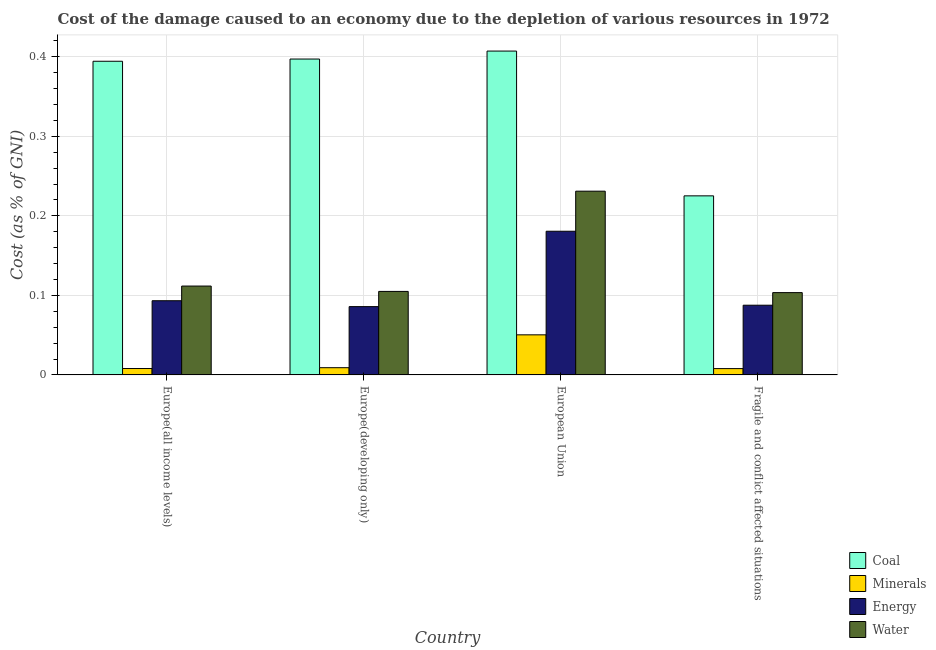How many different coloured bars are there?
Keep it short and to the point. 4. Are the number of bars on each tick of the X-axis equal?
Offer a very short reply. Yes. What is the label of the 3rd group of bars from the left?
Your response must be concise. European Union. In how many cases, is the number of bars for a given country not equal to the number of legend labels?
Give a very brief answer. 0. What is the cost of damage due to depletion of coal in Europe(all income levels)?
Keep it short and to the point. 0.39. Across all countries, what is the maximum cost of damage due to depletion of minerals?
Your answer should be compact. 0.05. Across all countries, what is the minimum cost of damage due to depletion of water?
Offer a very short reply. 0.1. In which country was the cost of damage due to depletion of water minimum?
Ensure brevity in your answer.  Fragile and conflict affected situations. What is the total cost of damage due to depletion of water in the graph?
Your answer should be compact. 0.55. What is the difference between the cost of damage due to depletion of energy in Europe(all income levels) and that in Europe(developing only)?
Provide a succinct answer. 0.01. What is the difference between the cost of damage due to depletion of energy in Europe(all income levels) and the cost of damage due to depletion of coal in Europe(developing only)?
Offer a very short reply. -0.3. What is the average cost of damage due to depletion of water per country?
Keep it short and to the point. 0.14. What is the difference between the cost of damage due to depletion of coal and cost of damage due to depletion of water in Europe(developing only)?
Provide a succinct answer. 0.29. What is the ratio of the cost of damage due to depletion of energy in Europe(all income levels) to that in Fragile and conflict affected situations?
Offer a very short reply. 1.06. Is the cost of damage due to depletion of water in European Union less than that in Fragile and conflict affected situations?
Your response must be concise. No. Is the difference between the cost of damage due to depletion of energy in European Union and Fragile and conflict affected situations greater than the difference between the cost of damage due to depletion of coal in European Union and Fragile and conflict affected situations?
Offer a very short reply. No. What is the difference between the highest and the second highest cost of damage due to depletion of energy?
Provide a short and direct response. 0.09. What is the difference between the highest and the lowest cost of damage due to depletion of energy?
Your answer should be compact. 0.09. In how many countries, is the cost of damage due to depletion of water greater than the average cost of damage due to depletion of water taken over all countries?
Ensure brevity in your answer.  1. Is it the case that in every country, the sum of the cost of damage due to depletion of water and cost of damage due to depletion of energy is greater than the sum of cost of damage due to depletion of coal and cost of damage due to depletion of minerals?
Offer a terse response. No. What does the 2nd bar from the left in Europe(developing only) represents?
Provide a short and direct response. Minerals. What does the 4th bar from the right in Europe(developing only) represents?
Provide a succinct answer. Coal. Is it the case that in every country, the sum of the cost of damage due to depletion of coal and cost of damage due to depletion of minerals is greater than the cost of damage due to depletion of energy?
Your answer should be compact. Yes. Are all the bars in the graph horizontal?
Provide a short and direct response. No. How many countries are there in the graph?
Offer a terse response. 4. What is the difference between two consecutive major ticks on the Y-axis?
Provide a succinct answer. 0.1. Are the values on the major ticks of Y-axis written in scientific E-notation?
Provide a succinct answer. No. Does the graph contain any zero values?
Make the answer very short. No. Does the graph contain grids?
Your response must be concise. Yes. Where does the legend appear in the graph?
Offer a terse response. Bottom right. How many legend labels are there?
Provide a succinct answer. 4. How are the legend labels stacked?
Give a very brief answer. Vertical. What is the title of the graph?
Give a very brief answer. Cost of the damage caused to an economy due to the depletion of various resources in 1972 . What is the label or title of the Y-axis?
Ensure brevity in your answer.  Cost (as % of GNI). What is the Cost (as % of GNI) of Coal in Europe(all income levels)?
Make the answer very short. 0.39. What is the Cost (as % of GNI) of Minerals in Europe(all income levels)?
Provide a succinct answer. 0.01. What is the Cost (as % of GNI) in Energy in Europe(all income levels)?
Your response must be concise. 0.09. What is the Cost (as % of GNI) of Water in Europe(all income levels)?
Your answer should be compact. 0.11. What is the Cost (as % of GNI) in Coal in Europe(developing only)?
Make the answer very short. 0.4. What is the Cost (as % of GNI) of Minerals in Europe(developing only)?
Your answer should be compact. 0.01. What is the Cost (as % of GNI) in Energy in Europe(developing only)?
Your answer should be very brief. 0.09. What is the Cost (as % of GNI) of Water in Europe(developing only)?
Your answer should be compact. 0.1. What is the Cost (as % of GNI) of Coal in European Union?
Offer a very short reply. 0.41. What is the Cost (as % of GNI) in Minerals in European Union?
Keep it short and to the point. 0.05. What is the Cost (as % of GNI) of Energy in European Union?
Offer a terse response. 0.18. What is the Cost (as % of GNI) in Water in European Union?
Your answer should be very brief. 0.23. What is the Cost (as % of GNI) in Coal in Fragile and conflict affected situations?
Make the answer very short. 0.23. What is the Cost (as % of GNI) in Minerals in Fragile and conflict affected situations?
Provide a short and direct response. 0.01. What is the Cost (as % of GNI) of Energy in Fragile and conflict affected situations?
Provide a succinct answer. 0.09. What is the Cost (as % of GNI) of Water in Fragile and conflict affected situations?
Offer a very short reply. 0.1. Across all countries, what is the maximum Cost (as % of GNI) of Coal?
Give a very brief answer. 0.41. Across all countries, what is the maximum Cost (as % of GNI) of Minerals?
Offer a terse response. 0.05. Across all countries, what is the maximum Cost (as % of GNI) in Energy?
Your answer should be compact. 0.18. Across all countries, what is the maximum Cost (as % of GNI) of Water?
Your answer should be compact. 0.23. Across all countries, what is the minimum Cost (as % of GNI) in Coal?
Your response must be concise. 0.23. Across all countries, what is the minimum Cost (as % of GNI) in Minerals?
Provide a succinct answer. 0.01. Across all countries, what is the minimum Cost (as % of GNI) in Energy?
Ensure brevity in your answer.  0.09. Across all countries, what is the minimum Cost (as % of GNI) in Water?
Your response must be concise. 0.1. What is the total Cost (as % of GNI) in Coal in the graph?
Make the answer very short. 1.42. What is the total Cost (as % of GNI) of Minerals in the graph?
Offer a terse response. 0.08. What is the total Cost (as % of GNI) of Energy in the graph?
Make the answer very short. 0.45. What is the total Cost (as % of GNI) in Water in the graph?
Keep it short and to the point. 0.55. What is the difference between the Cost (as % of GNI) of Coal in Europe(all income levels) and that in Europe(developing only)?
Your response must be concise. -0. What is the difference between the Cost (as % of GNI) in Minerals in Europe(all income levels) and that in Europe(developing only)?
Offer a very short reply. -0. What is the difference between the Cost (as % of GNI) in Energy in Europe(all income levels) and that in Europe(developing only)?
Provide a short and direct response. 0.01. What is the difference between the Cost (as % of GNI) in Water in Europe(all income levels) and that in Europe(developing only)?
Ensure brevity in your answer.  0.01. What is the difference between the Cost (as % of GNI) of Coal in Europe(all income levels) and that in European Union?
Provide a short and direct response. -0.01. What is the difference between the Cost (as % of GNI) in Minerals in Europe(all income levels) and that in European Union?
Provide a succinct answer. -0.04. What is the difference between the Cost (as % of GNI) in Energy in Europe(all income levels) and that in European Union?
Provide a short and direct response. -0.09. What is the difference between the Cost (as % of GNI) of Water in Europe(all income levels) and that in European Union?
Offer a terse response. -0.12. What is the difference between the Cost (as % of GNI) of Coal in Europe(all income levels) and that in Fragile and conflict affected situations?
Your answer should be compact. 0.17. What is the difference between the Cost (as % of GNI) in Energy in Europe(all income levels) and that in Fragile and conflict affected situations?
Your answer should be very brief. 0.01. What is the difference between the Cost (as % of GNI) of Water in Europe(all income levels) and that in Fragile and conflict affected situations?
Your answer should be compact. 0.01. What is the difference between the Cost (as % of GNI) of Coal in Europe(developing only) and that in European Union?
Offer a very short reply. -0.01. What is the difference between the Cost (as % of GNI) of Minerals in Europe(developing only) and that in European Union?
Your answer should be very brief. -0.04. What is the difference between the Cost (as % of GNI) of Energy in Europe(developing only) and that in European Union?
Provide a short and direct response. -0.09. What is the difference between the Cost (as % of GNI) of Water in Europe(developing only) and that in European Union?
Ensure brevity in your answer.  -0.13. What is the difference between the Cost (as % of GNI) in Coal in Europe(developing only) and that in Fragile and conflict affected situations?
Keep it short and to the point. 0.17. What is the difference between the Cost (as % of GNI) of Minerals in Europe(developing only) and that in Fragile and conflict affected situations?
Provide a succinct answer. 0. What is the difference between the Cost (as % of GNI) of Energy in Europe(developing only) and that in Fragile and conflict affected situations?
Keep it short and to the point. -0. What is the difference between the Cost (as % of GNI) in Water in Europe(developing only) and that in Fragile and conflict affected situations?
Offer a terse response. 0. What is the difference between the Cost (as % of GNI) in Coal in European Union and that in Fragile and conflict affected situations?
Offer a very short reply. 0.18. What is the difference between the Cost (as % of GNI) in Minerals in European Union and that in Fragile and conflict affected situations?
Your answer should be compact. 0.04. What is the difference between the Cost (as % of GNI) in Energy in European Union and that in Fragile and conflict affected situations?
Ensure brevity in your answer.  0.09. What is the difference between the Cost (as % of GNI) of Water in European Union and that in Fragile and conflict affected situations?
Offer a terse response. 0.13. What is the difference between the Cost (as % of GNI) in Coal in Europe(all income levels) and the Cost (as % of GNI) in Minerals in Europe(developing only)?
Keep it short and to the point. 0.39. What is the difference between the Cost (as % of GNI) of Coal in Europe(all income levels) and the Cost (as % of GNI) of Energy in Europe(developing only)?
Keep it short and to the point. 0.31. What is the difference between the Cost (as % of GNI) of Coal in Europe(all income levels) and the Cost (as % of GNI) of Water in Europe(developing only)?
Give a very brief answer. 0.29. What is the difference between the Cost (as % of GNI) in Minerals in Europe(all income levels) and the Cost (as % of GNI) in Energy in Europe(developing only)?
Provide a succinct answer. -0.08. What is the difference between the Cost (as % of GNI) in Minerals in Europe(all income levels) and the Cost (as % of GNI) in Water in Europe(developing only)?
Keep it short and to the point. -0.1. What is the difference between the Cost (as % of GNI) in Energy in Europe(all income levels) and the Cost (as % of GNI) in Water in Europe(developing only)?
Offer a very short reply. -0.01. What is the difference between the Cost (as % of GNI) of Coal in Europe(all income levels) and the Cost (as % of GNI) of Minerals in European Union?
Your response must be concise. 0.34. What is the difference between the Cost (as % of GNI) of Coal in Europe(all income levels) and the Cost (as % of GNI) of Energy in European Union?
Ensure brevity in your answer.  0.21. What is the difference between the Cost (as % of GNI) in Coal in Europe(all income levels) and the Cost (as % of GNI) in Water in European Union?
Make the answer very short. 0.16. What is the difference between the Cost (as % of GNI) of Minerals in Europe(all income levels) and the Cost (as % of GNI) of Energy in European Union?
Your answer should be compact. -0.17. What is the difference between the Cost (as % of GNI) of Minerals in Europe(all income levels) and the Cost (as % of GNI) of Water in European Union?
Offer a very short reply. -0.22. What is the difference between the Cost (as % of GNI) of Energy in Europe(all income levels) and the Cost (as % of GNI) of Water in European Union?
Your response must be concise. -0.14. What is the difference between the Cost (as % of GNI) of Coal in Europe(all income levels) and the Cost (as % of GNI) of Minerals in Fragile and conflict affected situations?
Provide a succinct answer. 0.39. What is the difference between the Cost (as % of GNI) in Coal in Europe(all income levels) and the Cost (as % of GNI) in Energy in Fragile and conflict affected situations?
Your answer should be very brief. 0.31. What is the difference between the Cost (as % of GNI) in Coal in Europe(all income levels) and the Cost (as % of GNI) in Water in Fragile and conflict affected situations?
Offer a very short reply. 0.29. What is the difference between the Cost (as % of GNI) in Minerals in Europe(all income levels) and the Cost (as % of GNI) in Energy in Fragile and conflict affected situations?
Your response must be concise. -0.08. What is the difference between the Cost (as % of GNI) in Minerals in Europe(all income levels) and the Cost (as % of GNI) in Water in Fragile and conflict affected situations?
Your answer should be compact. -0.1. What is the difference between the Cost (as % of GNI) in Energy in Europe(all income levels) and the Cost (as % of GNI) in Water in Fragile and conflict affected situations?
Offer a terse response. -0.01. What is the difference between the Cost (as % of GNI) in Coal in Europe(developing only) and the Cost (as % of GNI) in Minerals in European Union?
Your answer should be compact. 0.35. What is the difference between the Cost (as % of GNI) of Coal in Europe(developing only) and the Cost (as % of GNI) of Energy in European Union?
Your answer should be compact. 0.22. What is the difference between the Cost (as % of GNI) of Coal in Europe(developing only) and the Cost (as % of GNI) of Water in European Union?
Offer a very short reply. 0.17. What is the difference between the Cost (as % of GNI) in Minerals in Europe(developing only) and the Cost (as % of GNI) in Energy in European Union?
Give a very brief answer. -0.17. What is the difference between the Cost (as % of GNI) in Minerals in Europe(developing only) and the Cost (as % of GNI) in Water in European Union?
Keep it short and to the point. -0.22. What is the difference between the Cost (as % of GNI) in Energy in Europe(developing only) and the Cost (as % of GNI) in Water in European Union?
Offer a terse response. -0.15. What is the difference between the Cost (as % of GNI) in Coal in Europe(developing only) and the Cost (as % of GNI) in Minerals in Fragile and conflict affected situations?
Your response must be concise. 0.39. What is the difference between the Cost (as % of GNI) of Coal in Europe(developing only) and the Cost (as % of GNI) of Energy in Fragile and conflict affected situations?
Keep it short and to the point. 0.31. What is the difference between the Cost (as % of GNI) of Coal in Europe(developing only) and the Cost (as % of GNI) of Water in Fragile and conflict affected situations?
Keep it short and to the point. 0.29. What is the difference between the Cost (as % of GNI) in Minerals in Europe(developing only) and the Cost (as % of GNI) in Energy in Fragile and conflict affected situations?
Ensure brevity in your answer.  -0.08. What is the difference between the Cost (as % of GNI) in Minerals in Europe(developing only) and the Cost (as % of GNI) in Water in Fragile and conflict affected situations?
Give a very brief answer. -0.09. What is the difference between the Cost (as % of GNI) of Energy in Europe(developing only) and the Cost (as % of GNI) of Water in Fragile and conflict affected situations?
Ensure brevity in your answer.  -0.02. What is the difference between the Cost (as % of GNI) of Coal in European Union and the Cost (as % of GNI) of Minerals in Fragile and conflict affected situations?
Offer a very short reply. 0.4. What is the difference between the Cost (as % of GNI) of Coal in European Union and the Cost (as % of GNI) of Energy in Fragile and conflict affected situations?
Your answer should be compact. 0.32. What is the difference between the Cost (as % of GNI) in Coal in European Union and the Cost (as % of GNI) in Water in Fragile and conflict affected situations?
Give a very brief answer. 0.3. What is the difference between the Cost (as % of GNI) in Minerals in European Union and the Cost (as % of GNI) in Energy in Fragile and conflict affected situations?
Your response must be concise. -0.04. What is the difference between the Cost (as % of GNI) in Minerals in European Union and the Cost (as % of GNI) in Water in Fragile and conflict affected situations?
Your response must be concise. -0.05. What is the difference between the Cost (as % of GNI) of Energy in European Union and the Cost (as % of GNI) of Water in Fragile and conflict affected situations?
Give a very brief answer. 0.08. What is the average Cost (as % of GNI) in Coal per country?
Offer a terse response. 0.36. What is the average Cost (as % of GNI) of Minerals per country?
Your answer should be very brief. 0.02. What is the average Cost (as % of GNI) of Energy per country?
Your answer should be very brief. 0.11. What is the average Cost (as % of GNI) of Water per country?
Your response must be concise. 0.14. What is the difference between the Cost (as % of GNI) of Coal and Cost (as % of GNI) of Minerals in Europe(all income levels)?
Give a very brief answer. 0.39. What is the difference between the Cost (as % of GNI) in Coal and Cost (as % of GNI) in Energy in Europe(all income levels)?
Make the answer very short. 0.3. What is the difference between the Cost (as % of GNI) of Coal and Cost (as % of GNI) of Water in Europe(all income levels)?
Offer a terse response. 0.28. What is the difference between the Cost (as % of GNI) of Minerals and Cost (as % of GNI) of Energy in Europe(all income levels)?
Keep it short and to the point. -0.09. What is the difference between the Cost (as % of GNI) in Minerals and Cost (as % of GNI) in Water in Europe(all income levels)?
Your answer should be compact. -0.1. What is the difference between the Cost (as % of GNI) in Energy and Cost (as % of GNI) in Water in Europe(all income levels)?
Provide a short and direct response. -0.02. What is the difference between the Cost (as % of GNI) of Coal and Cost (as % of GNI) of Minerals in Europe(developing only)?
Your answer should be compact. 0.39. What is the difference between the Cost (as % of GNI) of Coal and Cost (as % of GNI) of Energy in Europe(developing only)?
Your answer should be compact. 0.31. What is the difference between the Cost (as % of GNI) in Coal and Cost (as % of GNI) in Water in Europe(developing only)?
Make the answer very short. 0.29. What is the difference between the Cost (as % of GNI) of Minerals and Cost (as % of GNI) of Energy in Europe(developing only)?
Keep it short and to the point. -0.08. What is the difference between the Cost (as % of GNI) in Minerals and Cost (as % of GNI) in Water in Europe(developing only)?
Offer a terse response. -0.1. What is the difference between the Cost (as % of GNI) of Energy and Cost (as % of GNI) of Water in Europe(developing only)?
Provide a succinct answer. -0.02. What is the difference between the Cost (as % of GNI) in Coal and Cost (as % of GNI) in Minerals in European Union?
Offer a terse response. 0.36. What is the difference between the Cost (as % of GNI) of Coal and Cost (as % of GNI) of Energy in European Union?
Ensure brevity in your answer.  0.23. What is the difference between the Cost (as % of GNI) of Coal and Cost (as % of GNI) of Water in European Union?
Your response must be concise. 0.18. What is the difference between the Cost (as % of GNI) of Minerals and Cost (as % of GNI) of Energy in European Union?
Offer a terse response. -0.13. What is the difference between the Cost (as % of GNI) in Minerals and Cost (as % of GNI) in Water in European Union?
Provide a short and direct response. -0.18. What is the difference between the Cost (as % of GNI) in Energy and Cost (as % of GNI) in Water in European Union?
Offer a terse response. -0.05. What is the difference between the Cost (as % of GNI) in Coal and Cost (as % of GNI) in Minerals in Fragile and conflict affected situations?
Offer a very short reply. 0.22. What is the difference between the Cost (as % of GNI) in Coal and Cost (as % of GNI) in Energy in Fragile and conflict affected situations?
Provide a succinct answer. 0.14. What is the difference between the Cost (as % of GNI) in Coal and Cost (as % of GNI) in Water in Fragile and conflict affected situations?
Your answer should be compact. 0.12. What is the difference between the Cost (as % of GNI) of Minerals and Cost (as % of GNI) of Energy in Fragile and conflict affected situations?
Offer a terse response. -0.08. What is the difference between the Cost (as % of GNI) in Minerals and Cost (as % of GNI) in Water in Fragile and conflict affected situations?
Offer a very short reply. -0.1. What is the difference between the Cost (as % of GNI) of Energy and Cost (as % of GNI) of Water in Fragile and conflict affected situations?
Offer a very short reply. -0.02. What is the ratio of the Cost (as % of GNI) in Minerals in Europe(all income levels) to that in Europe(developing only)?
Keep it short and to the point. 0.89. What is the ratio of the Cost (as % of GNI) of Energy in Europe(all income levels) to that in Europe(developing only)?
Offer a terse response. 1.09. What is the ratio of the Cost (as % of GNI) in Water in Europe(all income levels) to that in Europe(developing only)?
Offer a terse response. 1.06. What is the ratio of the Cost (as % of GNI) of Coal in Europe(all income levels) to that in European Union?
Ensure brevity in your answer.  0.97. What is the ratio of the Cost (as % of GNI) in Minerals in Europe(all income levels) to that in European Union?
Offer a very short reply. 0.16. What is the ratio of the Cost (as % of GNI) of Energy in Europe(all income levels) to that in European Union?
Provide a succinct answer. 0.52. What is the ratio of the Cost (as % of GNI) of Water in Europe(all income levels) to that in European Union?
Provide a succinct answer. 0.48. What is the ratio of the Cost (as % of GNI) in Coal in Europe(all income levels) to that in Fragile and conflict affected situations?
Ensure brevity in your answer.  1.75. What is the ratio of the Cost (as % of GNI) of Energy in Europe(all income levels) to that in Fragile and conflict affected situations?
Give a very brief answer. 1.06. What is the ratio of the Cost (as % of GNI) in Water in Europe(all income levels) to that in Fragile and conflict affected situations?
Ensure brevity in your answer.  1.08. What is the ratio of the Cost (as % of GNI) of Coal in Europe(developing only) to that in European Union?
Offer a terse response. 0.98. What is the ratio of the Cost (as % of GNI) in Minerals in Europe(developing only) to that in European Union?
Offer a terse response. 0.18. What is the ratio of the Cost (as % of GNI) of Energy in Europe(developing only) to that in European Union?
Keep it short and to the point. 0.48. What is the ratio of the Cost (as % of GNI) of Water in Europe(developing only) to that in European Union?
Your response must be concise. 0.45. What is the ratio of the Cost (as % of GNI) in Coal in Europe(developing only) to that in Fragile and conflict affected situations?
Your answer should be very brief. 1.76. What is the ratio of the Cost (as % of GNI) of Minerals in Europe(developing only) to that in Fragile and conflict affected situations?
Provide a short and direct response. 1.14. What is the ratio of the Cost (as % of GNI) in Energy in Europe(developing only) to that in Fragile and conflict affected situations?
Your answer should be compact. 0.98. What is the ratio of the Cost (as % of GNI) in Water in Europe(developing only) to that in Fragile and conflict affected situations?
Offer a terse response. 1.01. What is the ratio of the Cost (as % of GNI) in Coal in European Union to that in Fragile and conflict affected situations?
Make the answer very short. 1.81. What is the ratio of the Cost (as % of GNI) in Minerals in European Union to that in Fragile and conflict affected situations?
Make the answer very short. 6.35. What is the ratio of the Cost (as % of GNI) of Energy in European Union to that in Fragile and conflict affected situations?
Provide a succinct answer. 2.06. What is the ratio of the Cost (as % of GNI) of Water in European Union to that in Fragile and conflict affected situations?
Provide a succinct answer. 2.23. What is the difference between the highest and the second highest Cost (as % of GNI) in Minerals?
Provide a short and direct response. 0.04. What is the difference between the highest and the second highest Cost (as % of GNI) in Energy?
Give a very brief answer. 0.09. What is the difference between the highest and the second highest Cost (as % of GNI) of Water?
Your response must be concise. 0.12. What is the difference between the highest and the lowest Cost (as % of GNI) of Coal?
Your response must be concise. 0.18. What is the difference between the highest and the lowest Cost (as % of GNI) of Minerals?
Give a very brief answer. 0.04. What is the difference between the highest and the lowest Cost (as % of GNI) of Energy?
Make the answer very short. 0.09. What is the difference between the highest and the lowest Cost (as % of GNI) of Water?
Keep it short and to the point. 0.13. 